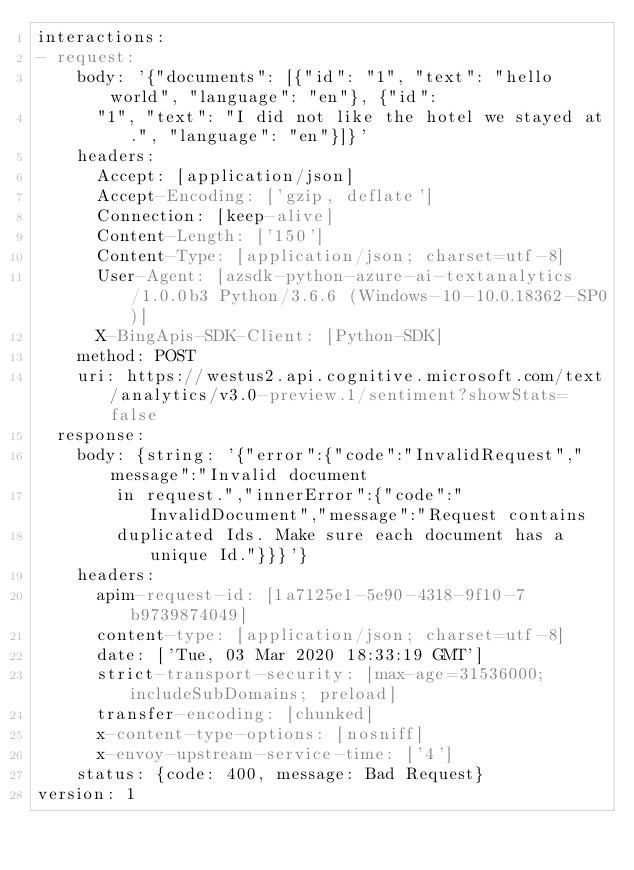Convert code to text. <code><loc_0><loc_0><loc_500><loc_500><_YAML_>interactions:
- request:
    body: '{"documents": [{"id": "1", "text": "hello world", "language": "en"}, {"id":
      "1", "text": "I did not like the hotel we stayed at.", "language": "en"}]}'
    headers:
      Accept: [application/json]
      Accept-Encoding: ['gzip, deflate']
      Connection: [keep-alive]
      Content-Length: ['150']
      Content-Type: [application/json; charset=utf-8]
      User-Agent: [azsdk-python-azure-ai-textanalytics/1.0.0b3 Python/3.6.6 (Windows-10-10.0.18362-SP0)]
      X-BingApis-SDK-Client: [Python-SDK]
    method: POST
    uri: https://westus2.api.cognitive.microsoft.com/text/analytics/v3.0-preview.1/sentiment?showStats=false
  response:
    body: {string: '{"error":{"code":"InvalidRequest","message":"Invalid document
        in request.","innerError":{"code":"InvalidDocument","message":"Request contains
        duplicated Ids. Make sure each document has a unique Id."}}}'}
    headers:
      apim-request-id: [1a7125e1-5e90-4318-9f10-7b9739874049]
      content-type: [application/json; charset=utf-8]
      date: ['Tue, 03 Mar 2020 18:33:19 GMT']
      strict-transport-security: [max-age=31536000; includeSubDomains; preload]
      transfer-encoding: [chunked]
      x-content-type-options: [nosniff]
      x-envoy-upstream-service-time: ['4']
    status: {code: 400, message: Bad Request}
version: 1
</code> 